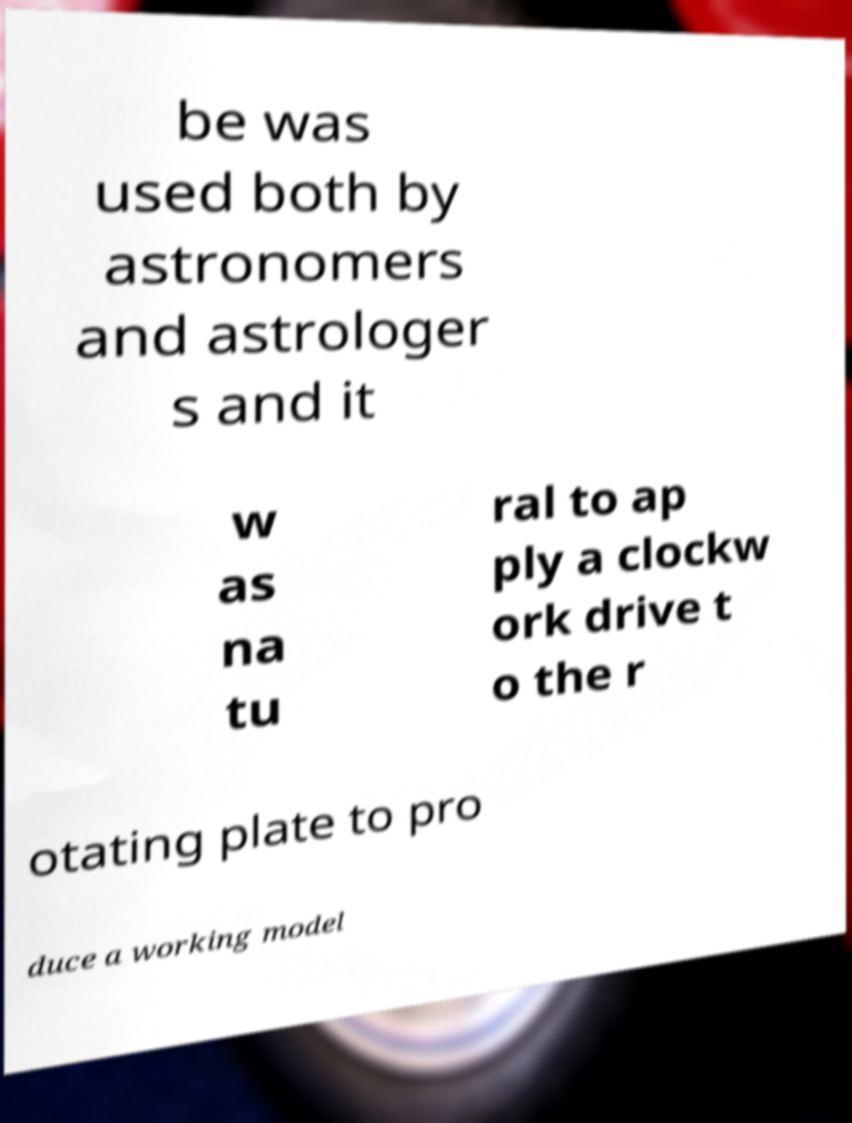What messages or text are displayed in this image? I need them in a readable, typed format. be was used both by astronomers and astrologer s and it w as na tu ral to ap ply a clockw ork drive t o the r otating plate to pro duce a working model 